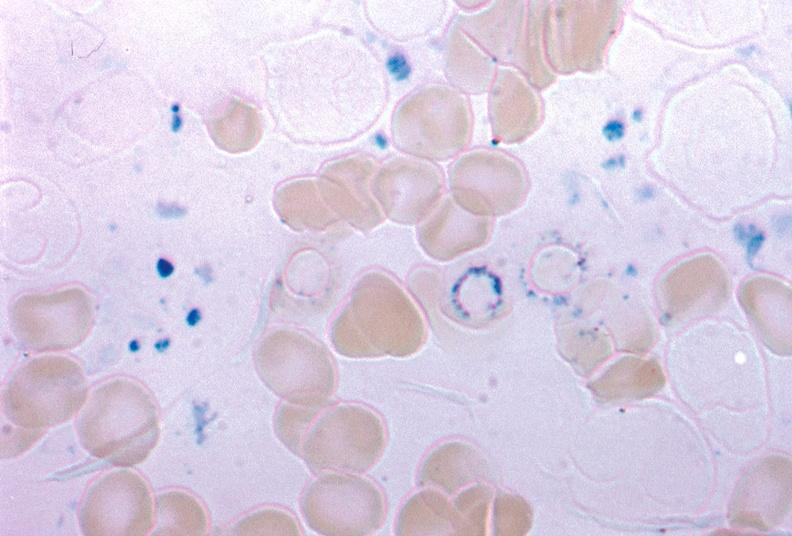what stain excellent example source unknown?
Answer the question using a single word or phrase. Iron 